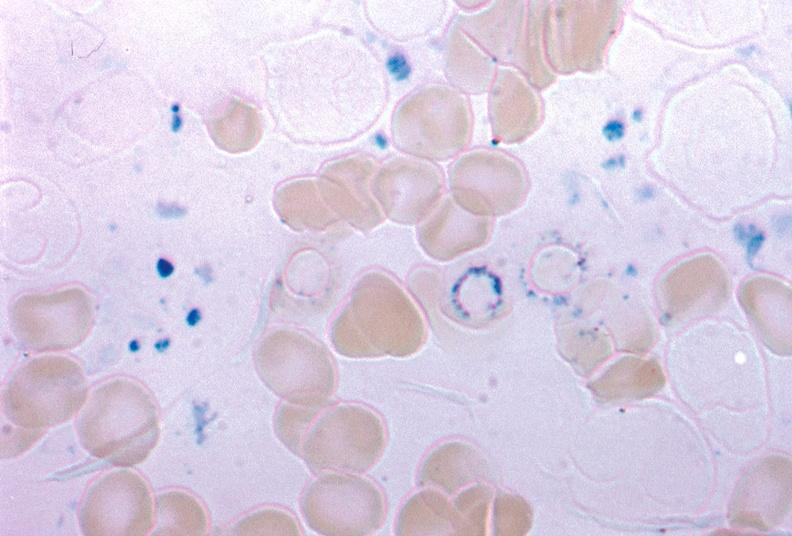what stain excellent example source unknown?
Answer the question using a single word or phrase. Iron 